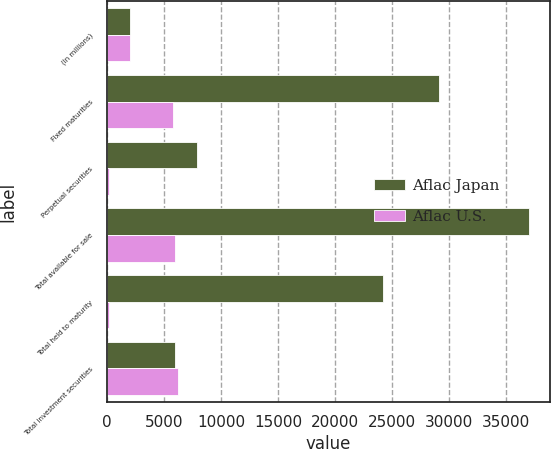Convert chart to OTSL. <chart><loc_0><loc_0><loc_500><loc_500><stacked_bar_chart><ecel><fcel>(In millions)<fcel>Fixed maturities<fcel>Perpetual securities<fcel>Total available for sale<fcel>Total held to maturity<fcel>Total investment securities<nl><fcel>Aflac Japan<fcel>2008<fcel>29140<fcel>7843<fcel>37010<fcel>24236<fcel>5976<nl><fcel>Aflac U.S.<fcel>2008<fcel>5772<fcel>204<fcel>5976<fcel>200<fcel>6176<nl></chart> 